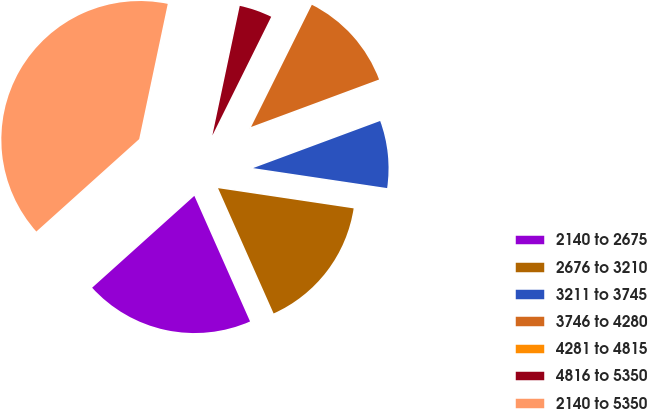<chart> <loc_0><loc_0><loc_500><loc_500><pie_chart><fcel>2140 to 2675<fcel>2676 to 3210<fcel>3211 to 3745<fcel>3746 to 4280<fcel>4281 to 4815<fcel>4816 to 5350<fcel>2140 to 5350<nl><fcel>19.99%<fcel>16.0%<fcel>8.01%<fcel>12.0%<fcel>0.02%<fcel>4.01%<fcel>39.97%<nl></chart> 